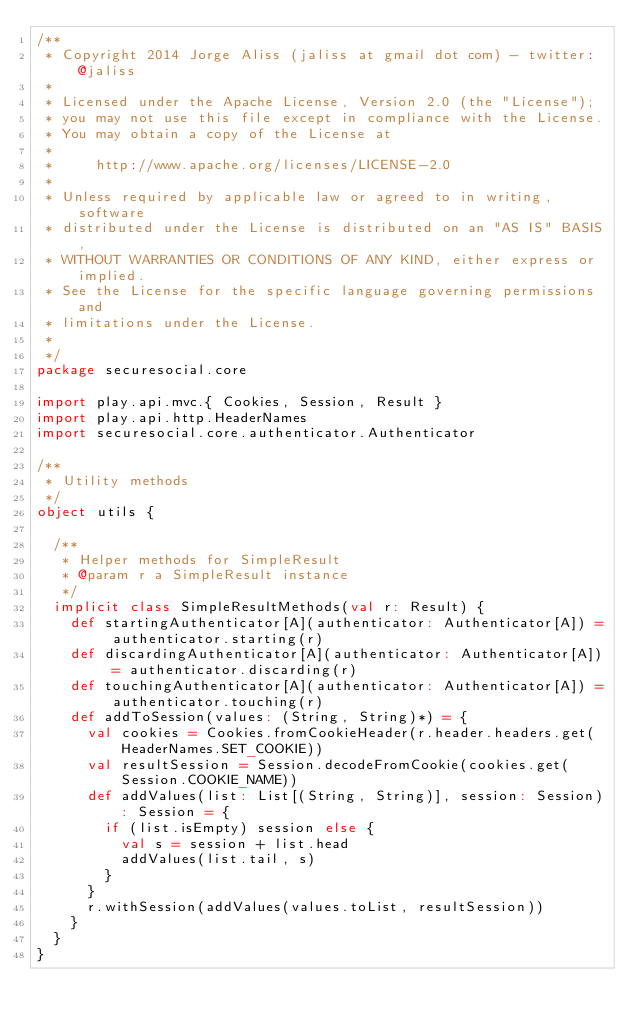<code> <loc_0><loc_0><loc_500><loc_500><_Scala_>/**
 * Copyright 2014 Jorge Aliss (jaliss at gmail dot com) - twitter: @jaliss
 *
 * Licensed under the Apache License, Version 2.0 (the "License");
 * you may not use this file except in compliance with the License.
 * You may obtain a copy of the License at
 *
 *     http://www.apache.org/licenses/LICENSE-2.0
 *
 * Unless required by applicable law or agreed to in writing, software
 * distributed under the License is distributed on an "AS IS" BASIS,
 * WITHOUT WARRANTIES OR CONDITIONS OF ANY KIND, either express or implied.
 * See the License for the specific language governing permissions and
 * limitations under the License.
 *
 */
package securesocial.core

import play.api.mvc.{ Cookies, Session, Result }
import play.api.http.HeaderNames
import securesocial.core.authenticator.Authenticator

/**
 * Utility methods
 */
object utils {

  /**
   * Helper methods for SimpleResult
   * @param r a SimpleResult instance
   */
  implicit class SimpleResultMethods(val r: Result) {
    def startingAuthenticator[A](authenticator: Authenticator[A]) = authenticator.starting(r)
    def discardingAuthenticator[A](authenticator: Authenticator[A]) = authenticator.discarding(r)
    def touchingAuthenticator[A](authenticator: Authenticator[A]) = authenticator.touching(r)
    def addToSession(values: (String, String)*) = {
      val cookies = Cookies.fromCookieHeader(r.header.headers.get(HeaderNames.SET_COOKIE))
      val resultSession = Session.decodeFromCookie(cookies.get(Session.COOKIE_NAME))
      def addValues(list: List[(String, String)], session: Session): Session = {
        if (list.isEmpty) session else {
          val s = session + list.head
          addValues(list.tail, s)
        }
      }
      r.withSession(addValues(values.toList, resultSession))
    }
  }
}</code> 